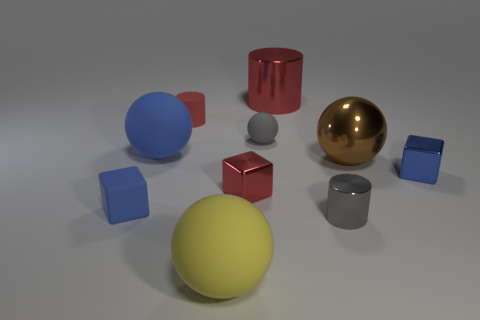Subtract all red cylinders. How many were subtracted if there are1red cylinders left? 1 Subtract all blocks. How many objects are left? 7 Subtract all tiny gray rubber spheres. Subtract all large shiny objects. How many objects are left? 7 Add 7 brown shiny spheres. How many brown shiny spheres are left? 8 Add 1 red shiny spheres. How many red shiny spheres exist? 1 Subtract 0 cyan cylinders. How many objects are left? 10 